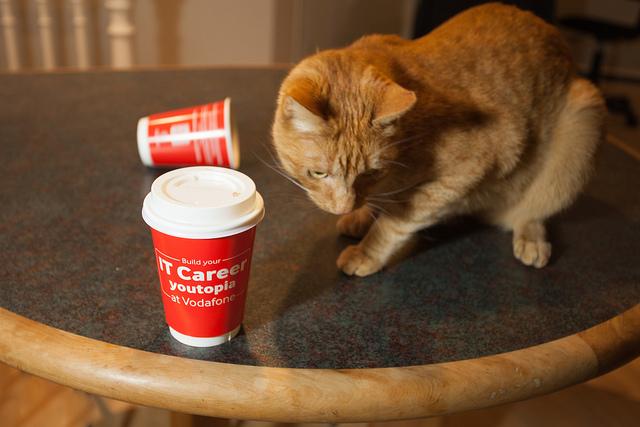Is the cat trying to catch a mouse?
Quick response, please. No. Is there pee in this cup?
Write a very short answer. No. How many cups have lids on them?
Answer briefly. 1. 